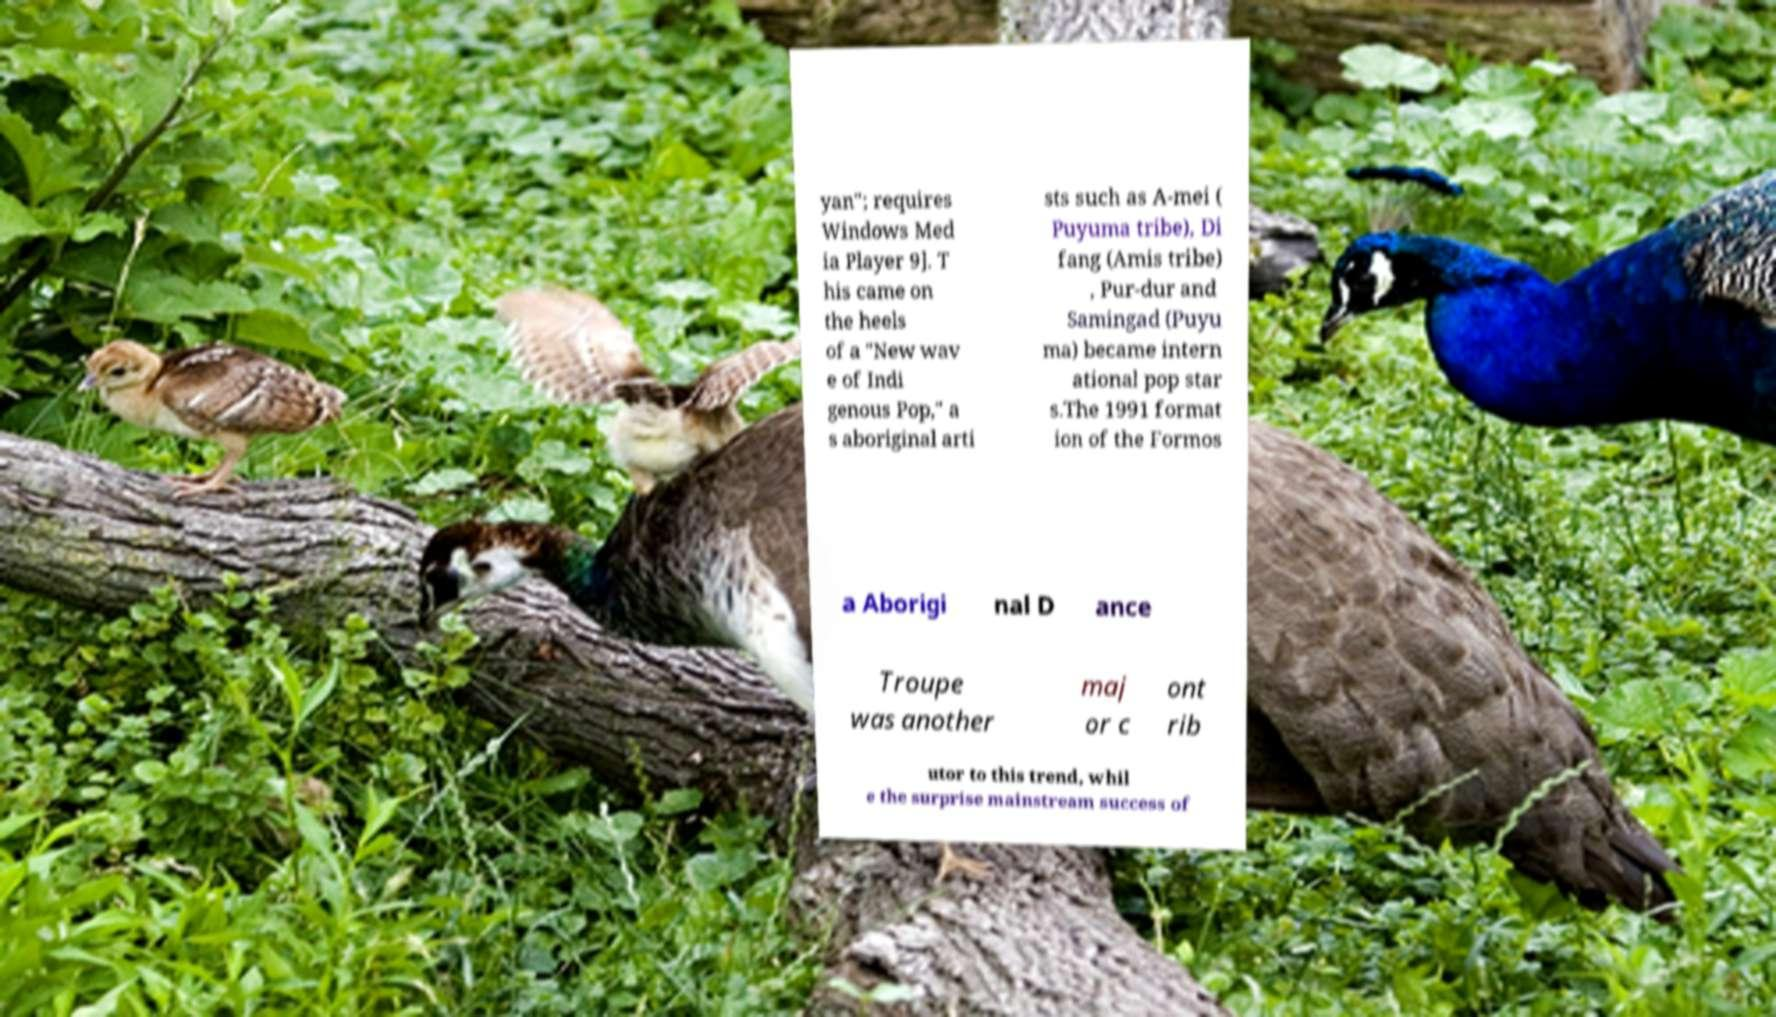There's text embedded in this image that I need extracted. Can you transcribe it verbatim? yan"; requires Windows Med ia Player 9]. T his came on the heels of a "New wav e of Indi genous Pop," a s aboriginal arti sts such as A-mei ( Puyuma tribe), Di fang (Amis tribe) , Pur-dur and Samingad (Puyu ma) became intern ational pop star s.The 1991 format ion of the Formos a Aborigi nal D ance Troupe was another maj or c ont rib utor to this trend, whil e the surprise mainstream success of 